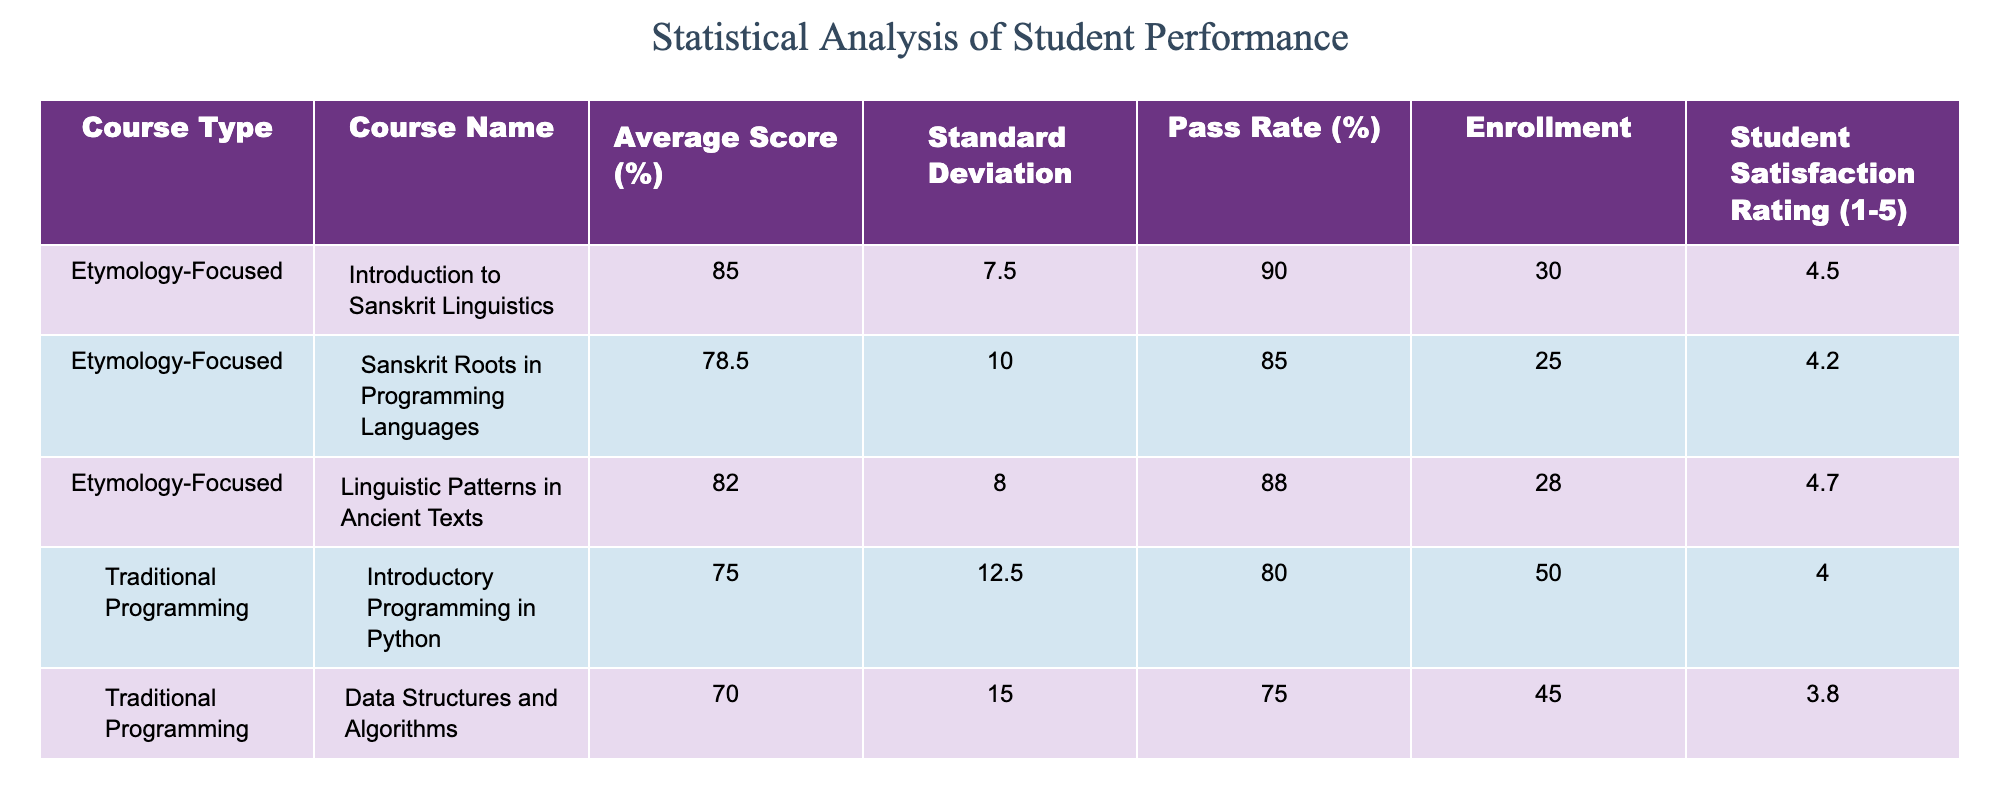What is the average score for the course "Introduction to Sanskrit Linguistics"? The average score for "Introduction to Sanskrit Linguistics" is listed directly in the table as 85.0%.
Answer: 85.0% What is the pass rate for "Data Structures and Algorithms"? The pass rate for "Data Structures and Algorithms" is found in the table as 75.0%.
Answer: 75.0% Which course has the highest student satisfaction rating? The highest student satisfaction rating in the table is 4.7, which corresponds to "Linguistic Patterns in Ancient Texts."
Answer: Linguistic Patterns in Ancient Texts What is the total enrollment for all etymology-focused courses combined? The total enrollment for etymology-focused courses is calculated by adding their enrollments: 30 (Introduction to Sanskrit Linguistics) + 25 (Sanskrit Roots in Programming Languages) + 28 (Linguistic Patterns in Ancient Texts) = 83.
Answer: 83 Is the standard deviation for any traditional programming course greater than 15? The standard deviations for traditional programming courses are 12.5 (Introductory Programming in Python), 15.0 (Data Structures and Algorithms), and 11.0 (Web Development Fundamentals). Since 15.0 is equal to 15, the answer is yes.
Answer: Yes What is the average student satisfaction rating of all courses combined? First, we sum the student satisfaction ratings: 4.5 (Introduction to Sanskrit Linguistics) + 4.2 (Sanskrit Roots in Programming Languages) + 4.7 (Linguistic Patterns in Ancient Texts) + 4.0 (Introductory Programming in Python) + 3.8 (Data Structures and Algorithms) + 4.1 (Web Development Fundamentals) = 25.3. Then we divide by the number of courses (6). Average = 25.3 / 6 ≈ 4.22.
Answer: 4.22 Does "Web Development Fundamentals" have a higher average score than the average score of all etymology-focused courses? The average score of etymology-focused courses is calculated as (85.0 + 78.5 + 82.0) / 3 = 81.83. "Web Development Fundamentals" has an average score of 72.5, which is lower than 81.83.
Answer: No What is the difference in pass rates between the etymology-focused courses and the traditional programming courses? For etymology-focused courses, the average pass rate is (90.0 + 85.0 + 88.0) / 3 = 87.67%. For traditional programming courses, the average pass rate is (80.0 + 75.0 + 77.0) / 3 = 77.33%. The difference is 87.67 - 77.33 = 10.34%.
Answer: 10.34% Which traditional programming course has the lowest student satisfaction rating? The student satisfaction ratings for traditional programming courses are 4.0 (Introductory Programming in Python), 3.8 (Data Structures and Algorithms), and 4.1 (Web Development Fundamentals). The lowest rating is 3.8, corresponding to "Data Structures and Algorithms."
Answer: Data Structures and Algorithms 